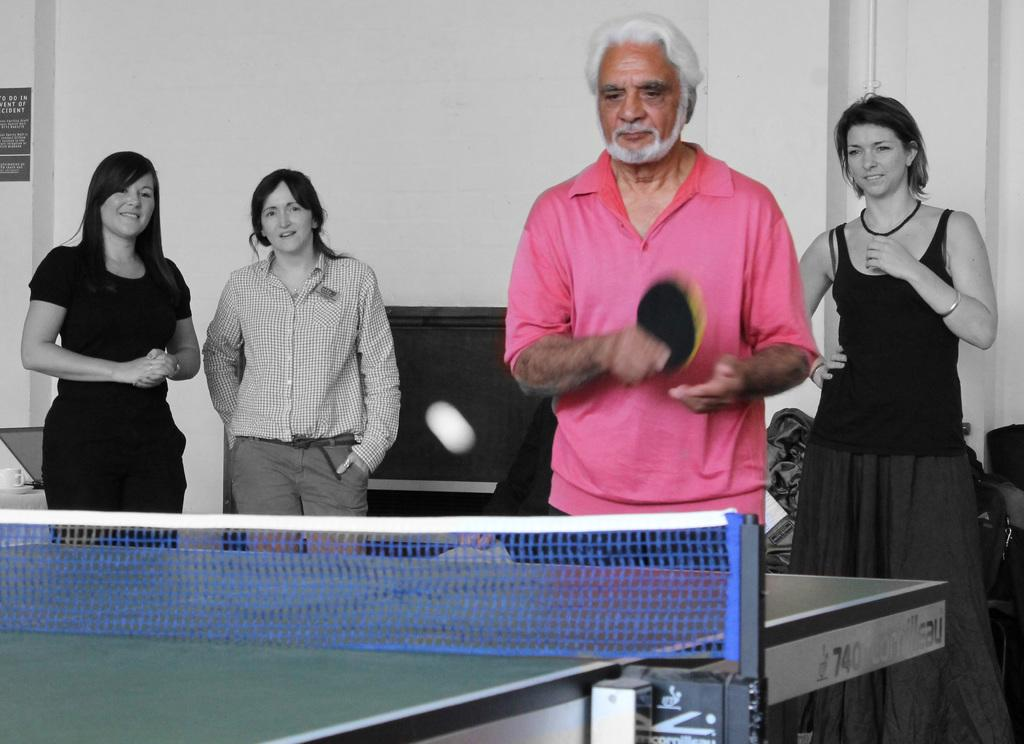How many people are in the image? There are three women and one man standing in the image. What activity is the man engaged in? The man is playing table tennis. What can be seen in the background of the image? There is a white wall in the background of the image. What color is the T-shirt worn by one of the men in the image? A man is wearing a pink T-shirt in the image. What is the title of the book the man is reading in the image? There is no book or reading activity depicted in the image; the man is playing table tennis. What is the relationship between the man and his brother in the image? There is no mention of a brother or any familial relationships in the image. 